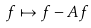<formula> <loc_0><loc_0><loc_500><loc_500>f \mapsto f - A f</formula> 